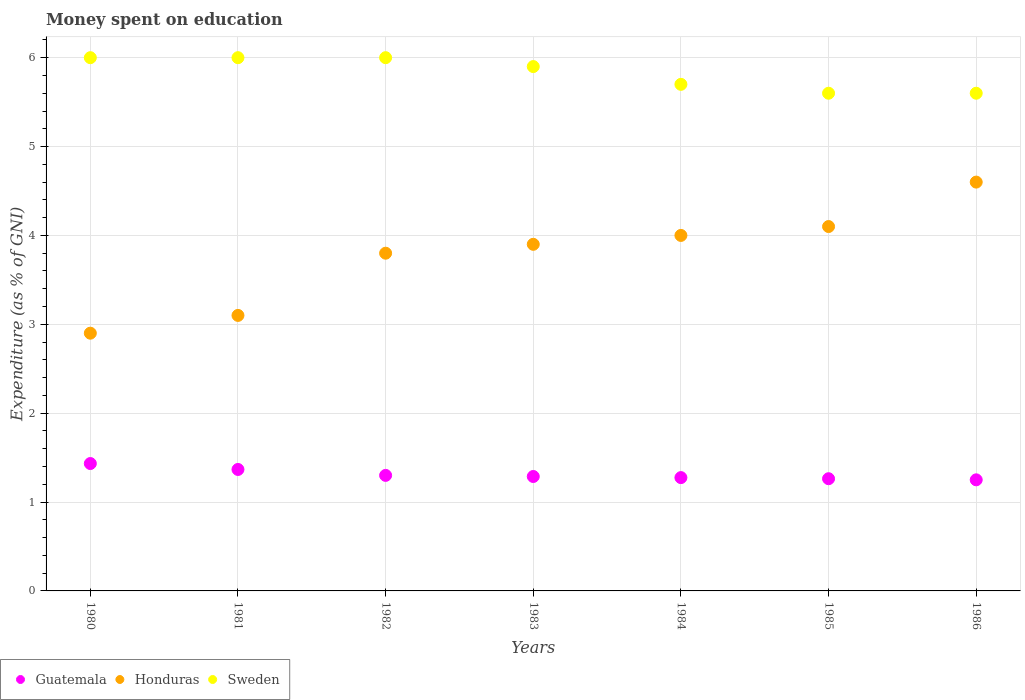How many different coloured dotlines are there?
Offer a very short reply. 3. Is the number of dotlines equal to the number of legend labels?
Your response must be concise. Yes. What is the amount of money spent on education in Guatemala in 1984?
Keep it short and to the point. 1.27. Across all years, what is the maximum amount of money spent on education in Sweden?
Your answer should be compact. 6. In which year was the amount of money spent on education in Sweden maximum?
Your answer should be very brief. 1980. In which year was the amount of money spent on education in Honduras minimum?
Ensure brevity in your answer.  1980. What is the total amount of money spent on education in Sweden in the graph?
Provide a short and direct response. 40.8. What is the difference between the amount of money spent on education in Sweden in 1983 and that in 1986?
Provide a short and direct response. 0.3. What is the difference between the amount of money spent on education in Honduras in 1983 and the amount of money spent on education in Sweden in 1982?
Give a very brief answer. -2.1. What is the average amount of money spent on education in Honduras per year?
Your answer should be very brief. 3.77. In the year 1983, what is the difference between the amount of money spent on education in Guatemala and amount of money spent on education in Honduras?
Your answer should be very brief. -2.61. In how many years, is the amount of money spent on education in Sweden greater than 1.8 %?
Provide a succinct answer. 7. What is the ratio of the amount of money spent on education in Guatemala in 1982 to that in 1986?
Make the answer very short. 1.04. Is the difference between the amount of money spent on education in Guatemala in 1981 and 1982 greater than the difference between the amount of money spent on education in Honduras in 1981 and 1982?
Your response must be concise. Yes. What is the difference between the highest and the lowest amount of money spent on education in Sweden?
Make the answer very short. 0.4. Does the amount of money spent on education in Sweden monotonically increase over the years?
Your response must be concise. No. Is the amount of money spent on education in Honduras strictly greater than the amount of money spent on education in Sweden over the years?
Your answer should be compact. No. How many years are there in the graph?
Make the answer very short. 7. What is the difference between two consecutive major ticks on the Y-axis?
Ensure brevity in your answer.  1. Are the values on the major ticks of Y-axis written in scientific E-notation?
Offer a very short reply. No. What is the title of the graph?
Make the answer very short. Money spent on education. What is the label or title of the Y-axis?
Ensure brevity in your answer.  Expenditure (as % of GNI). What is the Expenditure (as % of GNI) of Guatemala in 1980?
Provide a succinct answer. 1.43. What is the Expenditure (as % of GNI) of Guatemala in 1981?
Your answer should be very brief. 1.37. What is the Expenditure (as % of GNI) of Sweden in 1982?
Provide a short and direct response. 6. What is the Expenditure (as % of GNI) in Guatemala in 1983?
Give a very brief answer. 1.29. What is the Expenditure (as % of GNI) of Honduras in 1983?
Offer a very short reply. 3.9. What is the Expenditure (as % of GNI) in Sweden in 1983?
Offer a very short reply. 5.9. What is the Expenditure (as % of GNI) in Guatemala in 1984?
Provide a succinct answer. 1.27. What is the Expenditure (as % of GNI) of Honduras in 1984?
Your answer should be compact. 4. What is the Expenditure (as % of GNI) of Sweden in 1984?
Make the answer very short. 5.7. What is the Expenditure (as % of GNI) of Guatemala in 1985?
Offer a terse response. 1.26. What is the Expenditure (as % of GNI) of Honduras in 1986?
Ensure brevity in your answer.  4.6. Across all years, what is the maximum Expenditure (as % of GNI) of Guatemala?
Make the answer very short. 1.43. Across all years, what is the maximum Expenditure (as % of GNI) of Sweden?
Provide a short and direct response. 6. Across all years, what is the minimum Expenditure (as % of GNI) in Guatemala?
Ensure brevity in your answer.  1.25. What is the total Expenditure (as % of GNI) in Guatemala in the graph?
Provide a short and direct response. 9.18. What is the total Expenditure (as % of GNI) in Honduras in the graph?
Offer a terse response. 26.4. What is the total Expenditure (as % of GNI) in Sweden in the graph?
Provide a short and direct response. 40.8. What is the difference between the Expenditure (as % of GNI) in Guatemala in 1980 and that in 1981?
Ensure brevity in your answer.  0.07. What is the difference between the Expenditure (as % of GNI) in Guatemala in 1980 and that in 1982?
Provide a short and direct response. 0.13. What is the difference between the Expenditure (as % of GNI) in Honduras in 1980 and that in 1982?
Your answer should be compact. -0.9. What is the difference between the Expenditure (as % of GNI) of Guatemala in 1980 and that in 1983?
Give a very brief answer. 0.15. What is the difference between the Expenditure (as % of GNI) of Sweden in 1980 and that in 1983?
Make the answer very short. 0.1. What is the difference between the Expenditure (as % of GNI) in Guatemala in 1980 and that in 1984?
Provide a short and direct response. 0.16. What is the difference between the Expenditure (as % of GNI) of Honduras in 1980 and that in 1984?
Provide a short and direct response. -1.1. What is the difference between the Expenditure (as % of GNI) in Guatemala in 1980 and that in 1985?
Your answer should be compact. 0.17. What is the difference between the Expenditure (as % of GNI) in Honduras in 1980 and that in 1985?
Keep it short and to the point. -1.2. What is the difference between the Expenditure (as % of GNI) in Sweden in 1980 and that in 1985?
Offer a very short reply. 0.4. What is the difference between the Expenditure (as % of GNI) in Guatemala in 1980 and that in 1986?
Your answer should be compact. 0.18. What is the difference between the Expenditure (as % of GNI) of Guatemala in 1981 and that in 1982?
Offer a terse response. 0.07. What is the difference between the Expenditure (as % of GNI) of Honduras in 1981 and that in 1982?
Give a very brief answer. -0.7. What is the difference between the Expenditure (as % of GNI) in Sweden in 1981 and that in 1982?
Provide a succinct answer. 0. What is the difference between the Expenditure (as % of GNI) of Guatemala in 1981 and that in 1983?
Provide a succinct answer. 0.08. What is the difference between the Expenditure (as % of GNI) in Sweden in 1981 and that in 1983?
Your answer should be very brief. 0.1. What is the difference between the Expenditure (as % of GNI) of Guatemala in 1981 and that in 1984?
Provide a succinct answer. 0.09. What is the difference between the Expenditure (as % of GNI) of Guatemala in 1981 and that in 1985?
Provide a short and direct response. 0.1. What is the difference between the Expenditure (as % of GNI) of Guatemala in 1981 and that in 1986?
Provide a succinct answer. 0.12. What is the difference between the Expenditure (as % of GNI) of Guatemala in 1982 and that in 1983?
Ensure brevity in your answer.  0.01. What is the difference between the Expenditure (as % of GNI) of Sweden in 1982 and that in 1983?
Provide a succinct answer. 0.1. What is the difference between the Expenditure (as % of GNI) of Guatemala in 1982 and that in 1984?
Your answer should be compact. 0.03. What is the difference between the Expenditure (as % of GNI) of Honduras in 1982 and that in 1984?
Keep it short and to the point. -0.2. What is the difference between the Expenditure (as % of GNI) in Guatemala in 1982 and that in 1985?
Offer a very short reply. 0.04. What is the difference between the Expenditure (as % of GNI) of Honduras in 1982 and that in 1985?
Make the answer very short. -0.3. What is the difference between the Expenditure (as % of GNI) in Guatemala in 1982 and that in 1986?
Make the answer very short. 0.05. What is the difference between the Expenditure (as % of GNI) of Honduras in 1982 and that in 1986?
Provide a short and direct response. -0.8. What is the difference between the Expenditure (as % of GNI) of Guatemala in 1983 and that in 1984?
Your answer should be very brief. 0.01. What is the difference between the Expenditure (as % of GNI) in Sweden in 1983 and that in 1984?
Make the answer very short. 0.2. What is the difference between the Expenditure (as % of GNI) in Guatemala in 1983 and that in 1985?
Your answer should be compact. 0.03. What is the difference between the Expenditure (as % of GNI) of Honduras in 1983 and that in 1985?
Your response must be concise. -0.2. What is the difference between the Expenditure (as % of GNI) in Guatemala in 1983 and that in 1986?
Your answer should be very brief. 0.04. What is the difference between the Expenditure (as % of GNI) in Honduras in 1983 and that in 1986?
Your response must be concise. -0.7. What is the difference between the Expenditure (as % of GNI) in Sweden in 1983 and that in 1986?
Give a very brief answer. 0.3. What is the difference between the Expenditure (as % of GNI) of Guatemala in 1984 and that in 1985?
Offer a terse response. 0.01. What is the difference between the Expenditure (as % of GNI) of Honduras in 1984 and that in 1985?
Provide a succinct answer. -0.1. What is the difference between the Expenditure (as % of GNI) in Guatemala in 1984 and that in 1986?
Provide a short and direct response. 0.03. What is the difference between the Expenditure (as % of GNI) in Sweden in 1984 and that in 1986?
Your answer should be compact. 0.1. What is the difference between the Expenditure (as % of GNI) in Guatemala in 1985 and that in 1986?
Give a very brief answer. 0.01. What is the difference between the Expenditure (as % of GNI) in Guatemala in 1980 and the Expenditure (as % of GNI) in Honduras in 1981?
Keep it short and to the point. -1.67. What is the difference between the Expenditure (as % of GNI) in Guatemala in 1980 and the Expenditure (as % of GNI) in Sweden in 1981?
Offer a terse response. -4.57. What is the difference between the Expenditure (as % of GNI) of Honduras in 1980 and the Expenditure (as % of GNI) of Sweden in 1981?
Provide a short and direct response. -3.1. What is the difference between the Expenditure (as % of GNI) in Guatemala in 1980 and the Expenditure (as % of GNI) in Honduras in 1982?
Keep it short and to the point. -2.37. What is the difference between the Expenditure (as % of GNI) in Guatemala in 1980 and the Expenditure (as % of GNI) in Sweden in 1982?
Ensure brevity in your answer.  -4.57. What is the difference between the Expenditure (as % of GNI) in Honduras in 1980 and the Expenditure (as % of GNI) in Sweden in 1982?
Your response must be concise. -3.1. What is the difference between the Expenditure (as % of GNI) in Guatemala in 1980 and the Expenditure (as % of GNI) in Honduras in 1983?
Provide a short and direct response. -2.47. What is the difference between the Expenditure (as % of GNI) of Guatemala in 1980 and the Expenditure (as % of GNI) of Sweden in 1983?
Provide a succinct answer. -4.47. What is the difference between the Expenditure (as % of GNI) in Guatemala in 1980 and the Expenditure (as % of GNI) in Honduras in 1984?
Your answer should be compact. -2.57. What is the difference between the Expenditure (as % of GNI) in Guatemala in 1980 and the Expenditure (as % of GNI) in Sweden in 1984?
Your answer should be very brief. -4.27. What is the difference between the Expenditure (as % of GNI) in Honduras in 1980 and the Expenditure (as % of GNI) in Sweden in 1984?
Your answer should be compact. -2.8. What is the difference between the Expenditure (as % of GNI) in Guatemala in 1980 and the Expenditure (as % of GNI) in Honduras in 1985?
Ensure brevity in your answer.  -2.67. What is the difference between the Expenditure (as % of GNI) in Guatemala in 1980 and the Expenditure (as % of GNI) in Sweden in 1985?
Your answer should be very brief. -4.17. What is the difference between the Expenditure (as % of GNI) in Honduras in 1980 and the Expenditure (as % of GNI) in Sweden in 1985?
Provide a short and direct response. -2.7. What is the difference between the Expenditure (as % of GNI) in Guatemala in 1980 and the Expenditure (as % of GNI) in Honduras in 1986?
Provide a short and direct response. -3.17. What is the difference between the Expenditure (as % of GNI) of Guatemala in 1980 and the Expenditure (as % of GNI) of Sweden in 1986?
Offer a very short reply. -4.17. What is the difference between the Expenditure (as % of GNI) in Honduras in 1980 and the Expenditure (as % of GNI) in Sweden in 1986?
Give a very brief answer. -2.7. What is the difference between the Expenditure (as % of GNI) of Guatemala in 1981 and the Expenditure (as % of GNI) of Honduras in 1982?
Give a very brief answer. -2.43. What is the difference between the Expenditure (as % of GNI) of Guatemala in 1981 and the Expenditure (as % of GNI) of Sweden in 1982?
Offer a terse response. -4.63. What is the difference between the Expenditure (as % of GNI) in Honduras in 1981 and the Expenditure (as % of GNI) in Sweden in 1982?
Your response must be concise. -2.9. What is the difference between the Expenditure (as % of GNI) in Guatemala in 1981 and the Expenditure (as % of GNI) in Honduras in 1983?
Ensure brevity in your answer.  -2.53. What is the difference between the Expenditure (as % of GNI) of Guatemala in 1981 and the Expenditure (as % of GNI) of Sweden in 1983?
Your response must be concise. -4.53. What is the difference between the Expenditure (as % of GNI) of Guatemala in 1981 and the Expenditure (as % of GNI) of Honduras in 1984?
Ensure brevity in your answer.  -2.63. What is the difference between the Expenditure (as % of GNI) of Guatemala in 1981 and the Expenditure (as % of GNI) of Sweden in 1984?
Ensure brevity in your answer.  -4.33. What is the difference between the Expenditure (as % of GNI) of Honduras in 1981 and the Expenditure (as % of GNI) of Sweden in 1984?
Keep it short and to the point. -2.6. What is the difference between the Expenditure (as % of GNI) in Guatemala in 1981 and the Expenditure (as % of GNI) in Honduras in 1985?
Provide a succinct answer. -2.73. What is the difference between the Expenditure (as % of GNI) in Guatemala in 1981 and the Expenditure (as % of GNI) in Sweden in 1985?
Provide a short and direct response. -4.23. What is the difference between the Expenditure (as % of GNI) of Honduras in 1981 and the Expenditure (as % of GNI) of Sweden in 1985?
Your answer should be very brief. -2.5. What is the difference between the Expenditure (as % of GNI) in Guatemala in 1981 and the Expenditure (as % of GNI) in Honduras in 1986?
Keep it short and to the point. -3.23. What is the difference between the Expenditure (as % of GNI) in Guatemala in 1981 and the Expenditure (as % of GNI) in Sweden in 1986?
Keep it short and to the point. -4.23. What is the difference between the Expenditure (as % of GNI) of Guatemala in 1982 and the Expenditure (as % of GNI) of Sweden in 1983?
Your response must be concise. -4.6. What is the difference between the Expenditure (as % of GNI) in Guatemala in 1982 and the Expenditure (as % of GNI) in Honduras in 1985?
Give a very brief answer. -2.8. What is the difference between the Expenditure (as % of GNI) of Guatemala in 1982 and the Expenditure (as % of GNI) of Sweden in 1986?
Make the answer very short. -4.3. What is the difference between the Expenditure (as % of GNI) in Honduras in 1982 and the Expenditure (as % of GNI) in Sweden in 1986?
Offer a very short reply. -1.8. What is the difference between the Expenditure (as % of GNI) of Guatemala in 1983 and the Expenditure (as % of GNI) of Honduras in 1984?
Ensure brevity in your answer.  -2.71. What is the difference between the Expenditure (as % of GNI) in Guatemala in 1983 and the Expenditure (as % of GNI) in Sweden in 1984?
Provide a short and direct response. -4.41. What is the difference between the Expenditure (as % of GNI) in Honduras in 1983 and the Expenditure (as % of GNI) in Sweden in 1984?
Provide a succinct answer. -1.8. What is the difference between the Expenditure (as % of GNI) of Guatemala in 1983 and the Expenditure (as % of GNI) of Honduras in 1985?
Provide a succinct answer. -2.81. What is the difference between the Expenditure (as % of GNI) in Guatemala in 1983 and the Expenditure (as % of GNI) in Sweden in 1985?
Your response must be concise. -4.31. What is the difference between the Expenditure (as % of GNI) of Guatemala in 1983 and the Expenditure (as % of GNI) of Honduras in 1986?
Ensure brevity in your answer.  -3.31. What is the difference between the Expenditure (as % of GNI) in Guatemala in 1983 and the Expenditure (as % of GNI) in Sweden in 1986?
Your response must be concise. -4.31. What is the difference between the Expenditure (as % of GNI) of Honduras in 1983 and the Expenditure (as % of GNI) of Sweden in 1986?
Offer a terse response. -1.7. What is the difference between the Expenditure (as % of GNI) of Guatemala in 1984 and the Expenditure (as % of GNI) of Honduras in 1985?
Make the answer very short. -2.83. What is the difference between the Expenditure (as % of GNI) in Guatemala in 1984 and the Expenditure (as % of GNI) in Sweden in 1985?
Your answer should be compact. -4.33. What is the difference between the Expenditure (as % of GNI) of Honduras in 1984 and the Expenditure (as % of GNI) of Sweden in 1985?
Ensure brevity in your answer.  -1.6. What is the difference between the Expenditure (as % of GNI) of Guatemala in 1984 and the Expenditure (as % of GNI) of Honduras in 1986?
Ensure brevity in your answer.  -3.33. What is the difference between the Expenditure (as % of GNI) in Guatemala in 1984 and the Expenditure (as % of GNI) in Sweden in 1986?
Keep it short and to the point. -4.33. What is the difference between the Expenditure (as % of GNI) of Guatemala in 1985 and the Expenditure (as % of GNI) of Honduras in 1986?
Offer a very short reply. -3.34. What is the difference between the Expenditure (as % of GNI) in Guatemala in 1985 and the Expenditure (as % of GNI) in Sweden in 1986?
Your answer should be compact. -4.34. What is the average Expenditure (as % of GNI) in Guatemala per year?
Your answer should be very brief. 1.31. What is the average Expenditure (as % of GNI) of Honduras per year?
Provide a succinct answer. 3.77. What is the average Expenditure (as % of GNI) in Sweden per year?
Your response must be concise. 5.83. In the year 1980, what is the difference between the Expenditure (as % of GNI) of Guatemala and Expenditure (as % of GNI) of Honduras?
Provide a succinct answer. -1.47. In the year 1980, what is the difference between the Expenditure (as % of GNI) of Guatemala and Expenditure (as % of GNI) of Sweden?
Provide a succinct answer. -4.57. In the year 1980, what is the difference between the Expenditure (as % of GNI) in Honduras and Expenditure (as % of GNI) in Sweden?
Ensure brevity in your answer.  -3.1. In the year 1981, what is the difference between the Expenditure (as % of GNI) in Guatemala and Expenditure (as % of GNI) in Honduras?
Make the answer very short. -1.73. In the year 1981, what is the difference between the Expenditure (as % of GNI) of Guatemala and Expenditure (as % of GNI) of Sweden?
Your answer should be compact. -4.63. In the year 1983, what is the difference between the Expenditure (as % of GNI) of Guatemala and Expenditure (as % of GNI) of Honduras?
Provide a short and direct response. -2.61. In the year 1983, what is the difference between the Expenditure (as % of GNI) in Guatemala and Expenditure (as % of GNI) in Sweden?
Ensure brevity in your answer.  -4.61. In the year 1983, what is the difference between the Expenditure (as % of GNI) of Honduras and Expenditure (as % of GNI) of Sweden?
Offer a terse response. -2. In the year 1984, what is the difference between the Expenditure (as % of GNI) of Guatemala and Expenditure (as % of GNI) of Honduras?
Make the answer very short. -2.73. In the year 1984, what is the difference between the Expenditure (as % of GNI) in Guatemala and Expenditure (as % of GNI) in Sweden?
Provide a succinct answer. -4.42. In the year 1984, what is the difference between the Expenditure (as % of GNI) of Honduras and Expenditure (as % of GNI) of Sweden?
Offer a terse response. -1.7. In the year 1985, what is the difference between the Expenditure (as % of GNI) of Guatemala and Expenditure (as % of GNI) of Honduras?
Your response must be concise. -2.84. In the year 1985, what is the difference between the Expenditure (as % of GNI) of Guatemala and Expenditure (as % of GNI) of Sweden?
Provide a short and direct response. -4.34. In the year 1985, what is the difference between the Expenditure (as % of GNI) in Honduras and Expenditure (as % of GNI) in Sweden?
Offer a terse response. -1.5. In the year 1986, what is the difference between the Expenditure (as % of GNI) of Guatemala and Expenditure (as % of GNI) of Honduras?
Offer a terse response. -3.35. In the year 1986, what is the difference between the Expenditure (as % of GNI) in Guatemala and Expenditure (as % of GNI) in Sweden?
Keep it short and to the point. -4.35. What is the ratio of the Expenditure (as % of GNI) in Guatemala in 1980 to that in 1981?
Your answer should be very brief. 1.05. What is the ratio of the Expenditure (as % of GNI) in Honduras in 1980 to that in 1981?
Ensure brevity in your answer.  0.94. What is the ratio of the Expenditure (as % of GNI) in Sweden in 1980 to that in 1981?
Keep it short and to the point. 1. What is the ratio of the Expenditure (as % of GNI) in Guatemala in 1980 to that in 1982?
Keep it short and to the point. 1.1. What is the ratio of the Expenditure (as % of GNI) in Honduras in 1980 to that in 1982?
Make the answer very short. 0.76. What is the ratio of the Expenditure (as % of GNI) in Guatemala in 1980 to that in 1983?
Provide a succinct answer. 1.11. What is the ratio of the Expenditure (as % of GNI) of Honduras in 1980 to that in 1983?
Ensure brevity in your answer.  0.74. What is the ratio of the Expenditure (as % of GNI) in Sweden in 1980 to that in 1983?
Provide a short and direct response. 1.02. What is the ratio of the Expenditure (as % of GNI) of Guatemala in 1980 to that in 1984?
Provide a short and direct response. 1.12. What is the ratio of the Expenditure (as % of GNI) of Honduras in 1980 to that in 1984?
Give a very brief answer. 0.72. What is the ratio of the Expenditure (as % of GNI) in Sweden in 1980 to that in 1984?
Keep it short and to the point. 1.05. What is the ratio of the Expenditure (as % of GNI) in Guatemala in 1980 to that in 1985?
Your response must be concise. 1.14. What is the ratio of the Expenditure (as % of GNI) of Honduras in 1980 to that in 1985?
Give a very brief answer. 0.71. What is the ratio of the Expenditure (as % of GNI) of Sweden in 1980 to that in 1985?
Keep it short and to the point. 1.07. What is the ratio of the Expenditure (as % of GNI) in Guatemala in 1980 to that in 1986?
Give a very brief answer. 1.15. What is the ratio of the Expenditure (as % of GNI) of Honduras in 1980 to that in 1986?
Provide a short and direct response. 0.63. What is the ratio of the Expenditure (as % of GNI) in Sweden in 1980 to that in 1986?
Provide a succinct answer. 1.07. What is the ratio of the Expenditure (as % of GNI) in Guatemala in 1981 to that in 1982?
Provide a short and direct response. 1.05. What is the ratio of the Expenditure (as % of GNI) of Honduras in 1981 to that in 1982?
Provide a succinct answer. 0.82. What is the ratio of the Expenditure (as % of GNI) of Guatemala in 1981 to that in 1983?
Your answer should be very brief. 1.06. What is the ratio of the Expenditure (as % of GNI) in Honduras in 1981 to that in 1983?
Make the answer very short. 0.79. What is the ratio of the Expenditure (as % of GNI) of Sweden in 1981 to that in 1983?
Give a very brief answer. 1.02. What is the ratio of the Expenditure (as % of GNI) in Guatemala in 1981 to that in 1984?
Provide a short and direct response. 1.07. What is the ratio of the Expenditure (as % of GNI) of Honduras in 1981 to that in 1984?
Your answer should be compact. 0.78. What is the ratio of the Expenditure (as % of GNI) in Sweden in 1981 to that in 1984?
Give a very brief answer. 1.05. What is the ratio of the Expenditure (as % of GNI) of Guatemala in 1981 to that in 1985?
Ensure brevity in your answer.  1.08. What is the ratio of the Expenditure (as % of GNI) of Honduras in 1981 to that in 1985?
Keep it short and to the point. 0.76. What is the ratio of the Expenditure (as % of GNI) of Sweden in 1981 to that in 1985?
Your response must be concise. 1.07. What is the ratio of the Expenditure (as % of GNI) in Guatemala in 1981 to that in 1986?
Provide a succinct answer. 1.09. What is the ratio of the Expenditure (as % of GNI) of Honduras in 1981 to that in 1986?
Make the answer very short. 0.67. What is the ratio of the Expenditure (as % of GNI) in Sweden in 1981 to that in 1986?
Your answer should be compact. 1.07. What is the ratio of the Expenditure (as % of GNI) in Guatemala in 1982 to that in 1983?
Provide a short and direct response. 1.01. What is the ratio of the Expenditure (as % of GNI) in Honduras in 1982 to that in 1983?
Your answer should be compact. 0.97. What is the ratio of the Expenditure (as % of GNI) of Sweden in 1982 to that in 1983?
Your answer should be compact. 1.02. What is the ratio of the Expenditure (as % of GNI) in Guatemala in 1982 to that in 1984?
Your answer should be very brief. 1.02. What is the ratio of the Expenditure (as % of GNI) of Honduras in 1982 to that in 1984?
Keep it short and to the point. 0.95. What is the ratio of the Expenditure (as % of GNI) of Sweden in 1982 to that in 1984?
Your response must be concise. 1.05. What is the ratio of the Expenditure (as % of GNI) of Guatemala in 1982 to that in 1985?
Provide a succinct answer. 1.03. What is the ratio of the Expenditure (as % of GNI) of Honduras in 1982 to that in 1985?
Offer a very short reply. 0.93. What is the ratio of the Expenditure (as % of GNI) of Sweden in 1982 to that in 1985?
Your answer should be compact. 1.07. What is the ratio of the Expenditure (as % of GNI) of Guatemala in 1982 to that in 1986?
Ensure brevity in your answer.  1.04. What is the ratio of the Expenditure (as % of GNI) of Honduras in 1982 to that in 1986?
Provide a short and direct response. 0.83. What is the ratio of the Expenditure (as % of GNI) in Sweden in 1982 to that in 1986?
Provide a short and direct response. 1.07. What is the ratio of the Expenditure (as % of GNI) in Guatemala in 1983 to that in 1984?
Give a very brief answer. 1.01. What is the ratio of the Expenditure (as % of GNI) in Sweden in 1983 to that in 1984?
Provide a short and direct response. 1.04. What is the ratio of the Expenditure (as % of GNI) in Guatemala in 1983 to that in 1985?
Your response must be concise. 1.02. What is the ratio of the Expenditure (as % of GNI) of Honduras in 1983 to that in 1985?
Give a very brief answer. 0.95. What is the ratio of the Expenditure (as % of GNI) of Sweden in 1983 to that in 1985?
Your response must be concise. 1.05. What is the ratio of the Expenditure (as % of GNI) in Guatemala in 1983 to that in 1986?
Keep it short and to the point. 1.03. What is the ratio of the Expenditure (as % of GNI) of Honduras in 1983 to that in 1986?
Provide a short and direct response. 0.85. What is the ratio of the Expenditure (as % of GNI) in Sweden in 1983 to that in 1986?
Keep it short and to the point. 1.05. What is the ratio of the Expenditure (as % of GNI) of Guatemala in 1984 to that in 1985?
Give a very brief answer. 1.01. What is the ratio of the Expenditure (as % of GNI) in Honduras in 1984 to that in 1985?
Your answer should be compact. 0.98. What is the ratio of the Expenditure (as % of GNI) of Sweden in 1984 to that in 1985?
Offer a very short reply. 1.02. What is the ratio of the Expenditure (as % of GNI) of Guatemala in 1984 to that in 1986?
Make the answer very short. 1.02. What is the ratio of the Expenditure (as % of GNI) in Honduras in 1984 to that in 1986?
Keep it short and to the point. 0.87. What is the ratio of the Expenditure (as % of GNI) in Sweden in 1984 to that in 1986?
Provide a succinct answer. 1.02. What is the ratio of the Expenditure (as % of GNI) of Honduras in 1985 to that in 1986?
Your response must be concise. 0.89. What is the difference between the highest and the second highest Expenditure (as % of GNI) in Guatemala?
Your answer should be compact. 0.07. What is the difference between the highest and the second highest Expenditure (as % of GNI) in Honduras?
Give a very brief answer. 0.5. What is the difference between the highest and the second highest Expenditure (as % of GNI) in Sweden?
Keep it short and to the point. 0. What is the difference between the highest and the lowest Expenditure (as % of GNI) of Guatemala?
Offer a very short reply. 0.18. What is the difference between the highest and the lowest Expenditure (as % of GNI) of Honduras?
Offer a terse response. 1.7. What is the difference between the highest and the lowest Expenditure (as % of GNI) in Sweden?
Give a very brief answer. 0.4. 